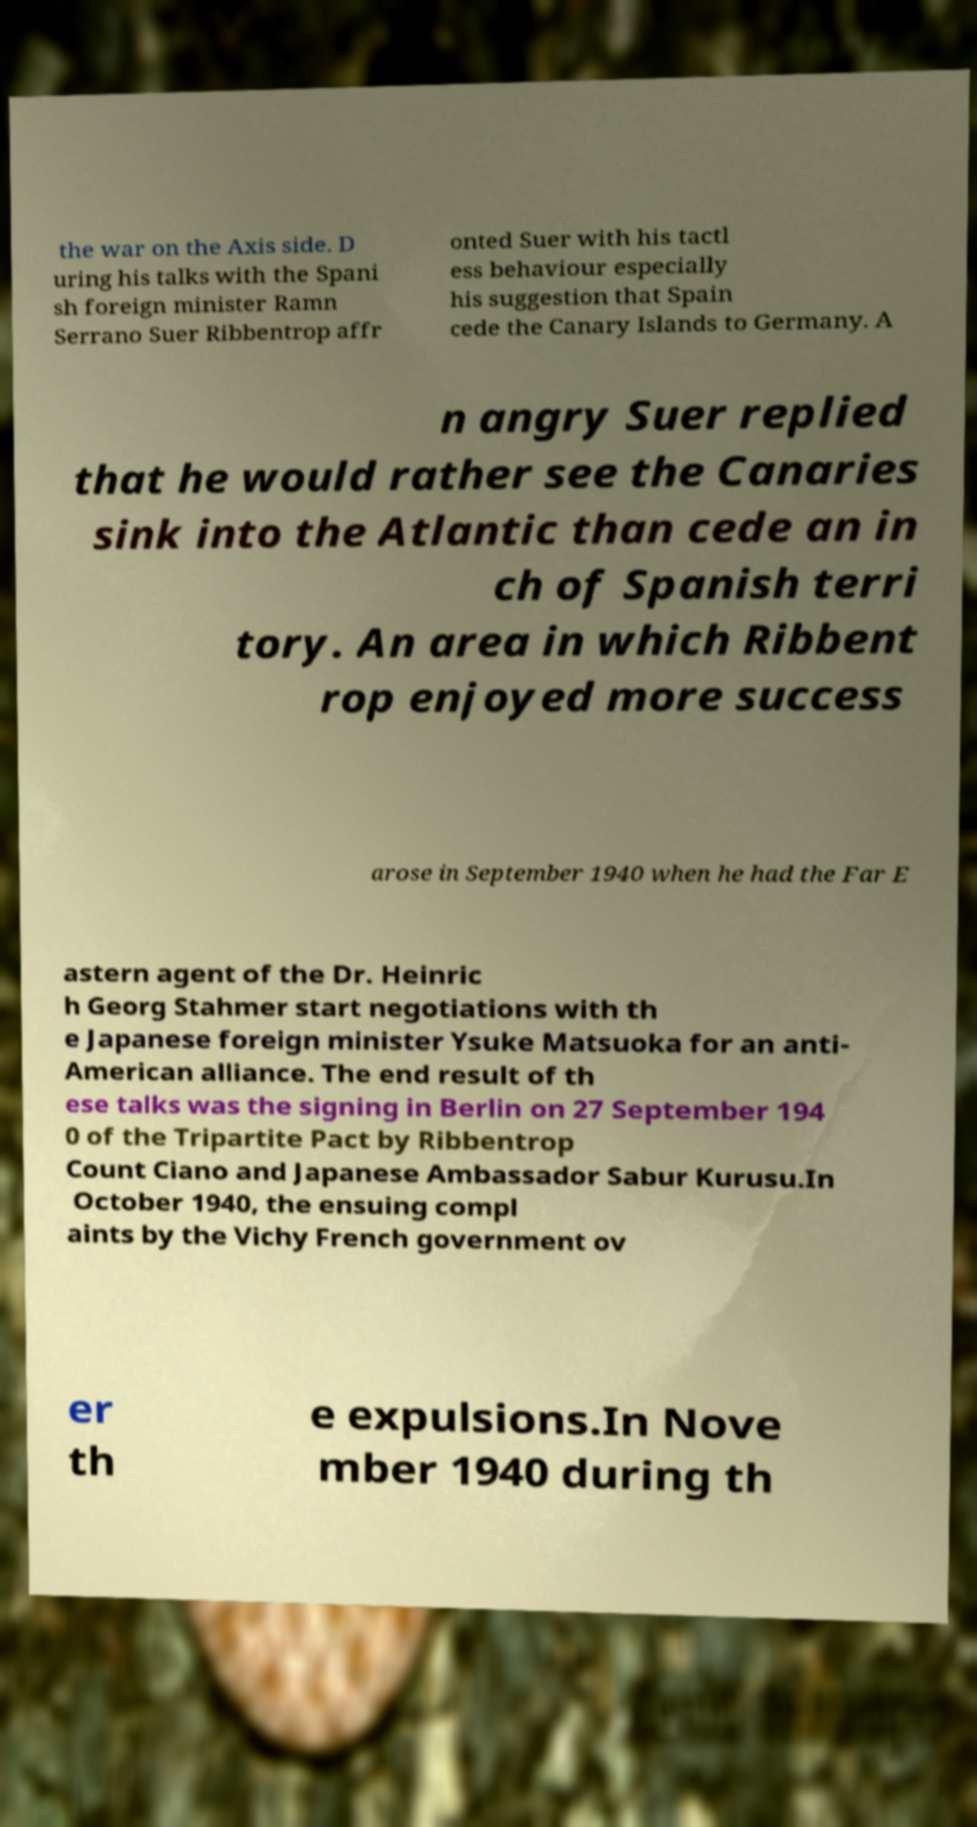Could you assist in decoding the text presented in this image and type it out clearly? the war on the Axis side. D uring his talks with the Spani sh foreign minister Ramn Serrano Suer Ribbentrop affr onted Suer with his tactl ess behaviour especially his suggestion that Spain cede the Canary Islands to Germany. A n angry Suer replied that he would rather see the Canaries sink into the Atlantic than cede an in ch of Spanish terri tory. An area in which Ribbent rop enjoyed more success arose in September 1940 when he had the Far E astern agent of the Dr. Heinric h Georg Stahmer start negotiations with th e Japanese foreign minister Ysuke Matsuoka for an anti- American alliance. The end result of th ese talks was the signing in Berlin on 27 September 194 0 of the Tripartite Pact by Ribbentrop Count Ciano and Japanese Ambassador Sabur Kurusu.In October 1940, the ensuing compl aints by the Vichy French government ov er th e expulsions.In Nove mber 1940 during th 